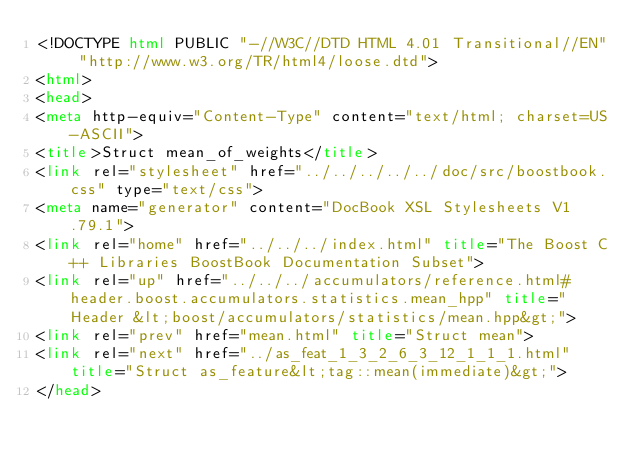<code> <loc_0><loc_0><loc_500><loc_500><_HTML_><!DOCTYPE html PUBLIC "-//W3C//DTD HTML 4.01 Transitional//EN" "http://www.w3.org/TR/html4/loose.dtd">
<html>
<head>
<meta http-equiv="Content-Type" content="text/html; charset=US-ASCII">
<title>Struct mean_of_weights</title>
<link rel="stylesheet" href="../../../../../doc/src/boostbook.css" type="text/css">
<meta name="generator" content="DocBook XSL Stylesheets V1.79.1">
<link rel="home" href="../../../index.html" title="The Boost C++ Libraries BoostBook Documentation Subset">
<link rel="up" href="../../../accumulators/reference.html#header.boost.accumulators.statistics.mean_hpp" title="Header &lt;boost/accumulators/statistics/mean.hpp&gt;">
<link rel="prev" href="mean.html" title="Struct mean">
<link rel="next" href="../as_feat_1_3_2_6_3_12_1_1_1.html" title="Struct as_feature&lt;tag::mean(immediate)&gt;">
</head></code> 